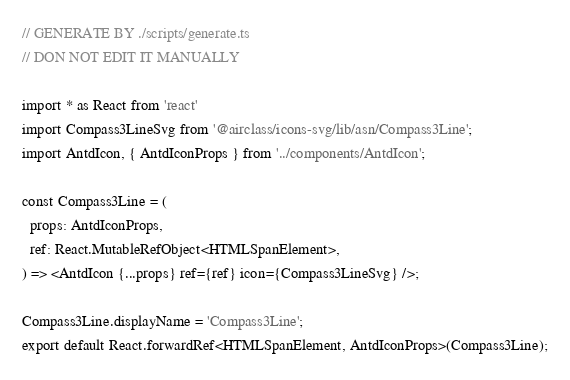<code> <loc_0><loc_0><loc_500><loc_500><_TypeScript_>// GENERATE BY ./scripts/generate.ts
// DON NOT EDIT IT MANUALLY

import * as React from 'react'
import Compass3LineSvg from '@airclass/icons-svg/lib/asn/Compass3Line';
import AntdIcon, { AntdIconProps } from '../components/AntdIcon';

const Compass3Line = (
  props: AntdIconProps,
  ref: React.MutableRefObject<HTMLSpanElement>,
) => <AntdIcon {...props} ref={ref} icon={Compass3LineSvg} />;

Compass3Line.displayName = 'Compass3Line';
export default React.forwardRef<HTMLSpanElement, AntdIconProps>(Compass3Line);</code> 